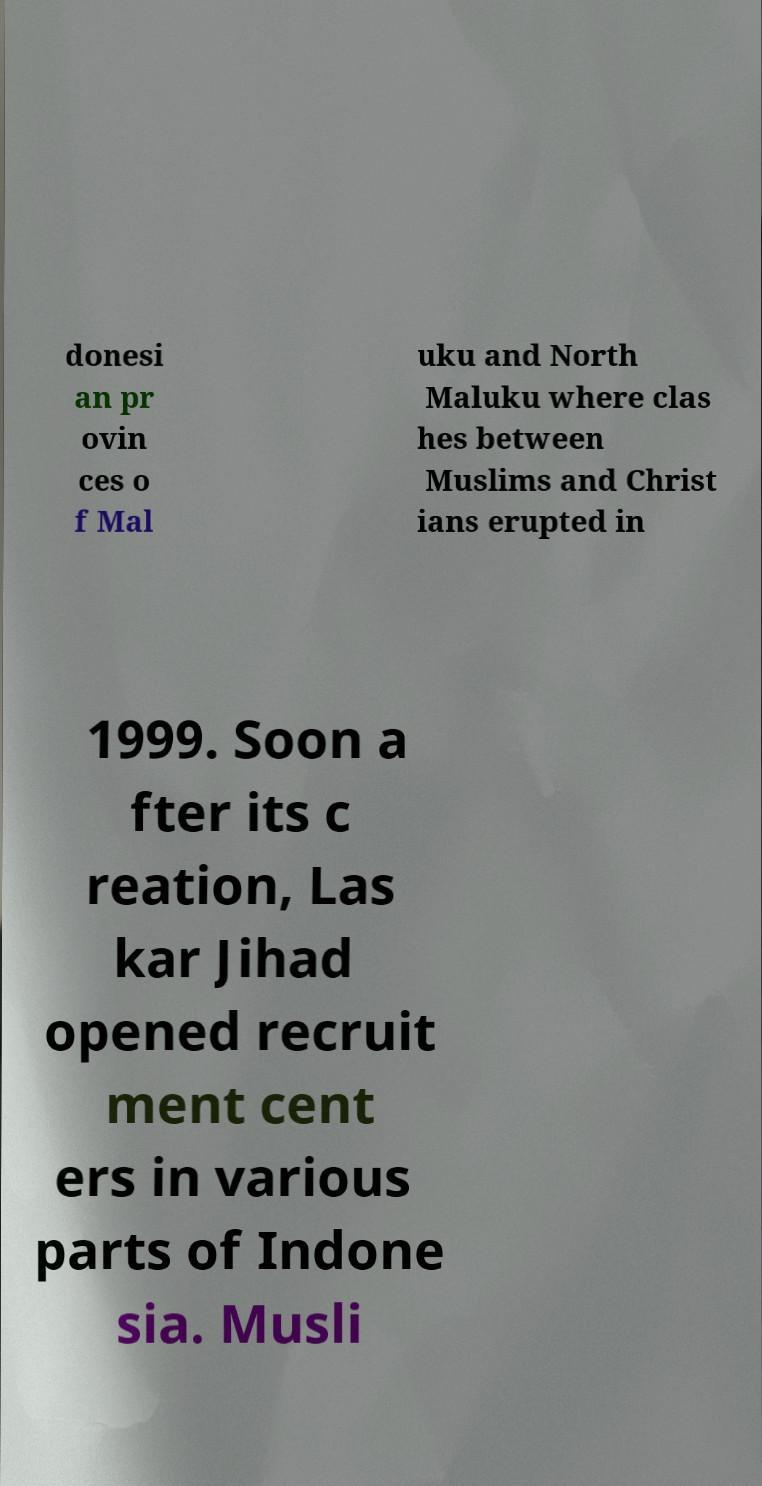Could you extract and type out the text from this image? donesi an pr ovin ces o f Mal uku and North Maluku where clas hes between Muslims and Christ ians erupted in 1999. Soon a fter its c reation, Las kar Jihad opened recruit ment cent ers in various parts of Indone sia. Musli 